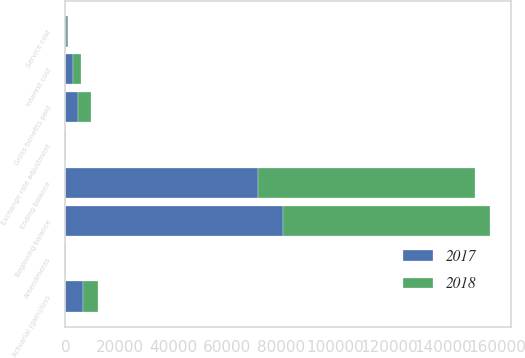Convert chart. <chart><loc_0><loc_0><loc_500><loc_500><stacked_bar_chart><ecel><fcel>Beginning balance<fcel>Service cost<fcel>Interest cost<fcel>Amendments<fcel>Actuarial (gain)/loss<fcel>Gross benefits paid<fcel>Exchange rate adjustment<fcel>Ending balance<nl><fcel>2017<fcel>80393<fcel>430<fcel>2781<fcel>377<fcel>6352<fcel>4700<fcel>21<fcel>71424<nl><fcel>2018<fcel>76745<fcel>402<fcel>2991<fcel>7<fcel>5653<fcel>4658<fcel>18<fcel>80393<nl></chart> 